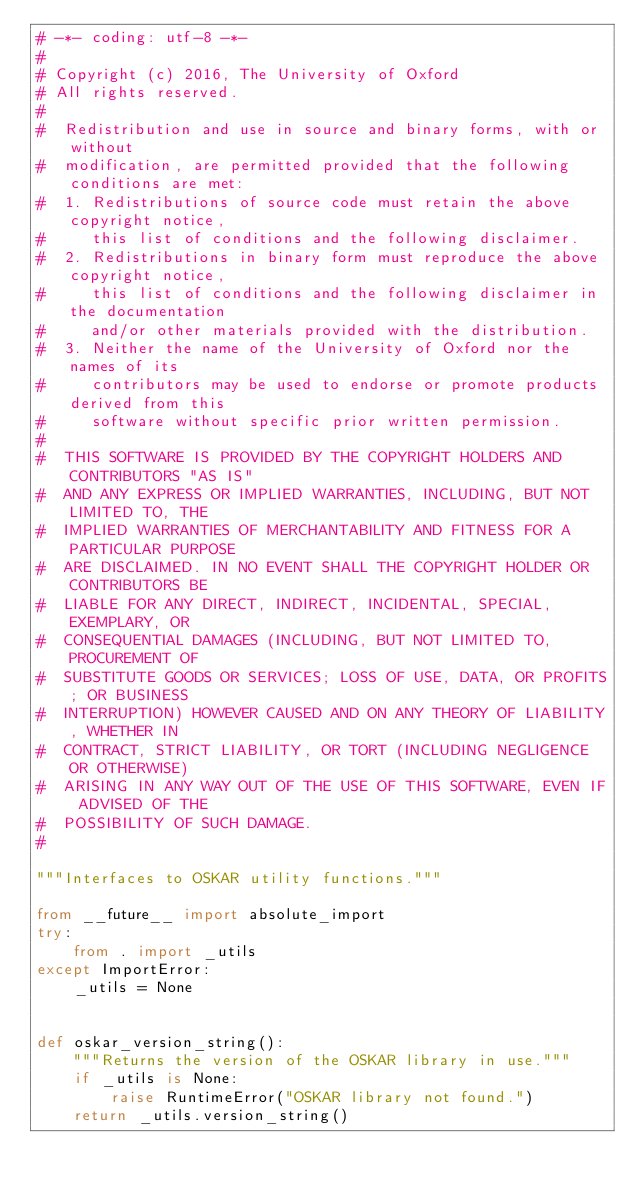<code> <loc_0><loc_0><loc_500><loc_500><_Python_># -*- coding: utf-8 -*-
#
# Copyright (c) 2016, The University of Oxford
# All rights reserved.
#
#  Redistribution and use in source and binary forms, with or without
#  modification, are permitted provided that the following conditions are met:
#  1. Redistributions of source code must retain the above copyright notice,
#     this list of conditions and the following disclaimer.
#  2. Redistributions in binary form must reproduce the above copyright notice,
#     this list of conditions and the following disclaimer in the documentation
#     and/or other materials provided with the distribution.
#  3. Neither the name of the University of Oxford nor the names of its
#     contributors may be used to endorse or promote products derived from this
#     software without specific prior written permission.
#
#  THIS SOFTWARE IS PROVIDED BY THE COPYRIGHT HOLDERS AND CONTRIBUTORS "AS IS"
#  AND ANY EXPRESS OR IMPLIED WARRANTIES, INCLUDING, BUT NOT LIMITED TO, THE
#  IMPLIED WARRANTIES OF MERCHANTABILITY AND FITNESS FOR A PARTICULAR PURPOSE
#  ARE DISCLAIMED. IN NO EVENT SHALL THE COPYRIGHT HOLDER OR CONTRIBUTORS BE
#  LIABLE FOR ANY DIRECT, INDIRECT, INCIDENTAL, SPECIAL, EXEMPLARY, OR
#  CONSEQUENTIAL DAMAGES (INCLUDING, BUT NOT LIMITED TO, PROCUREMENT OF
#  SUBSTITUTE GOODS OR SERVICES; LOSS OF USE, DATA, OR PROFITS; OR BUSINESS
#  INTERRUPTION) HOWEVER CAUSED AND ON ANY THEORY OF LIABILITY, WHETHER IN
#  CONTRACT, STRICT LIABILITY, OR TORT (INCLUDING NEGLIGENCE OR OTHERWISE)
#  ARISING IN ANY WAY OUT OF THE USE OF THIS SOFTWARE, EVEN IF ADVISED OF THE
#  POSSIBILITY OF SUCH DAMAGE.
#

"""Interfaces to OSKAR utility functions."""

from __future__ import absolute_import
try:
    from . import _utils
except ImportError:
    _utils = None


def oskar_version_string():
    """Returns the version of the OSKAR library in use."""
    if _utils is None:
        raise RuntimeError("OSKAR library not found.")
    return _utils.version_string()
</code> 